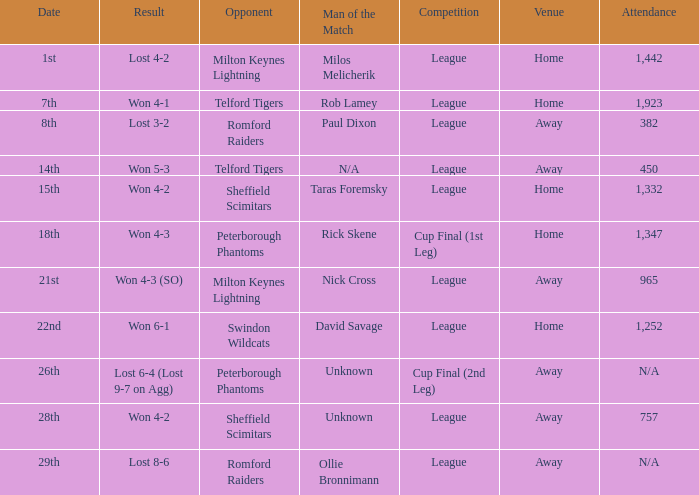On what date was the venue Away and the result was lost 6-4 (lost 9-7 on agg)? 26th. 